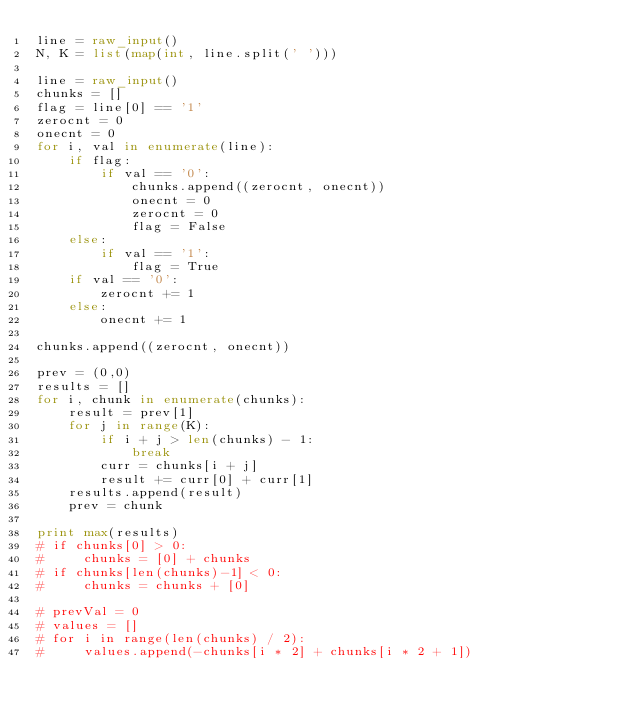<code> <loc_0><loc_0><loc_500><loc_500><_Python_>line = raw_input()
N, K = list(map(int, line.split(' ')))

line = raw_input()
chunks = []
flag = line[0] == '1'
zerocnt = 0
onecnt = 0
for i, val in enumerate(line):
    if flag:
        if val == '0':
            chunks.append((zerocnt, onecnt))
            onecnt = 0
            zerocnt = 0
            flag = False
    else:
        if val == '1':
            flag = True
    if val == '0':
        zerocnt += 1
    else:
        onecnt += 1
   
chunks.append((zerocnt, onecnt))

prev = (0,0)
results = []
for i, chunk in enumerate(chunks):
    result = prev[1] 
    for j in range(K):
        if i + j > len(chunks) - 1:
            break
        curr = chunks[i + j]
        result += curr[0] + curr[1]
    results.append(result)
    prev = chunk

print max(results)
# if chunks[0] > 0:
#     chunks = [0] + chunks
# if chunks[len(chunks)-1] < 0:
#     chunks = chunks + [0]

# prevVal = 0
# values = []
# for i in range(len(chunks) / 2):
#     values.append(-chunks[i * 2] + chunks[i * 2 + 1])</code> 